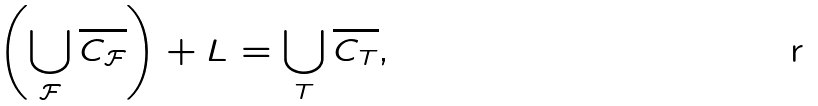Convert formula to latex. <formula><loc_0><loc_0><loc_500><loc_500>\left ( \bigcup _ { \mathcal { F } } \overline { C _ { \mathcal { F } } } \right ) + L = \bigcup _ { T } \overline { C _ { T } } ,</formula> 